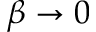Convert formula to latex. <formula><loc_0><loc_0><loc_500><loc_500>\beta \to 0</formula> 